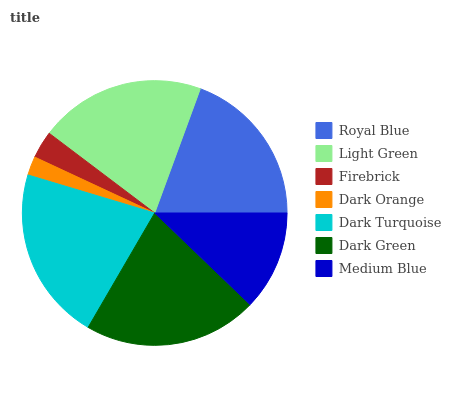Is Dark Orange the minimum?
Answer yes or no. Yes. Is Dark Turquoise the maximum?
Answer yes or no. Yes. Is Light Green the minimum?
Answer yes or no. No. Is Light Green the maximum?
Answer yes or no. No. Is Light Green greater than Royal Blue?
Answer yes or no. Yes. Is Royal Blue less than Light Green?
Answer yes or no. Yes. Is Royal Blue greater than Light Green?
Answer yes or no. No. Is Light Green less than Royal Blue?
Answer yes or no. No. Is Royal Blue the high median?
Answer yes or no. Yes. Is Royal Blue the low median?
Answer yes or no. Yes. Is Light Green the high median?
Answer yes or no. No. Is Dark Turquoise the low median?
Answer yes or no. No. 